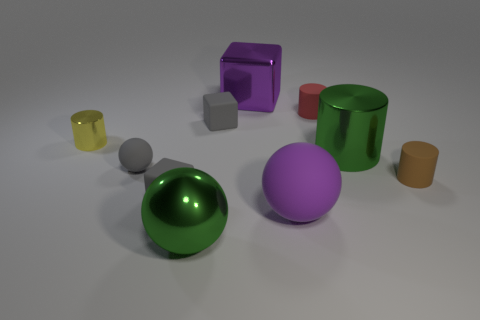Subtract all blocks. How many objects are left? 7 Add 7 gray blocks. How many gray blocks are left? 9 Add 9 big red matte cubes. How many big red matte cubes exist? 9 Subtract 0 cyan spheres. How many objects are left? 10 Subtract all gray spheres. Subtract all big red matte spheres. How many objects are left? 9 